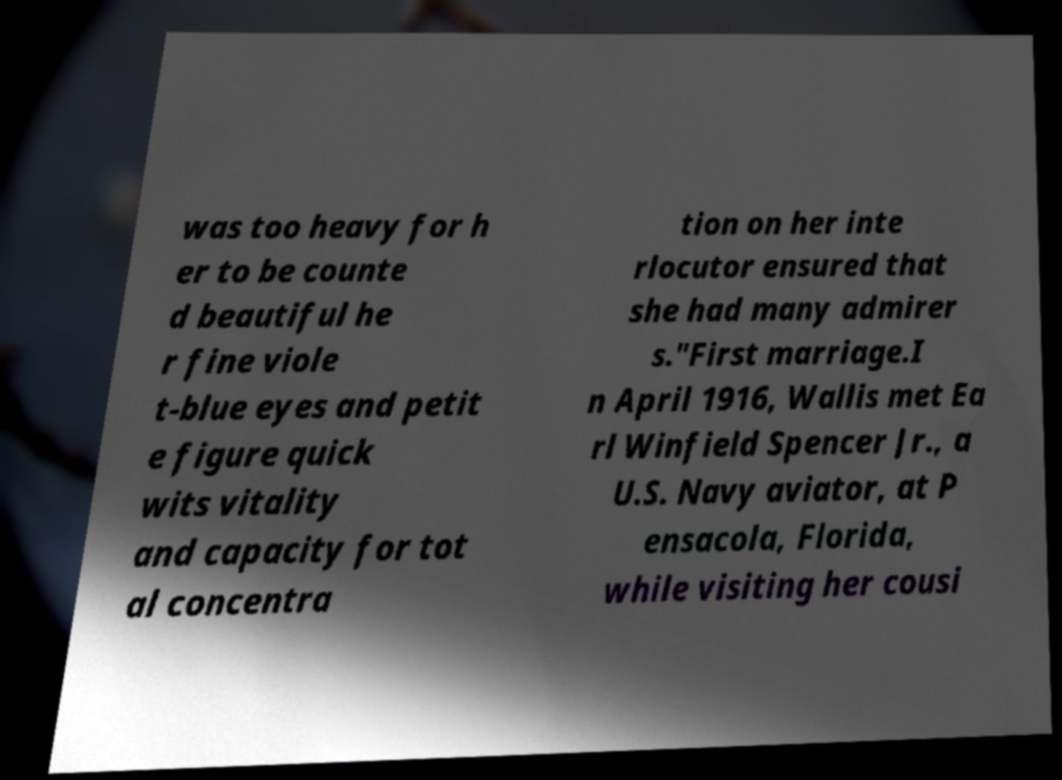Could you extract and type out the text from this image? was too heavy for h er to be counte d beautiful he r fine viole t-blue eyes and petit e figure quick wits vitality and capacity for tot al concentra tion on her inte rlocutor ensured that she had many admirer s."First marriage.I n April 1916, Wallis met Ea rl Winfield Spencer Jr., a U.S. Navy aviator, at P ensacola, Florida, while visiting her cousi 